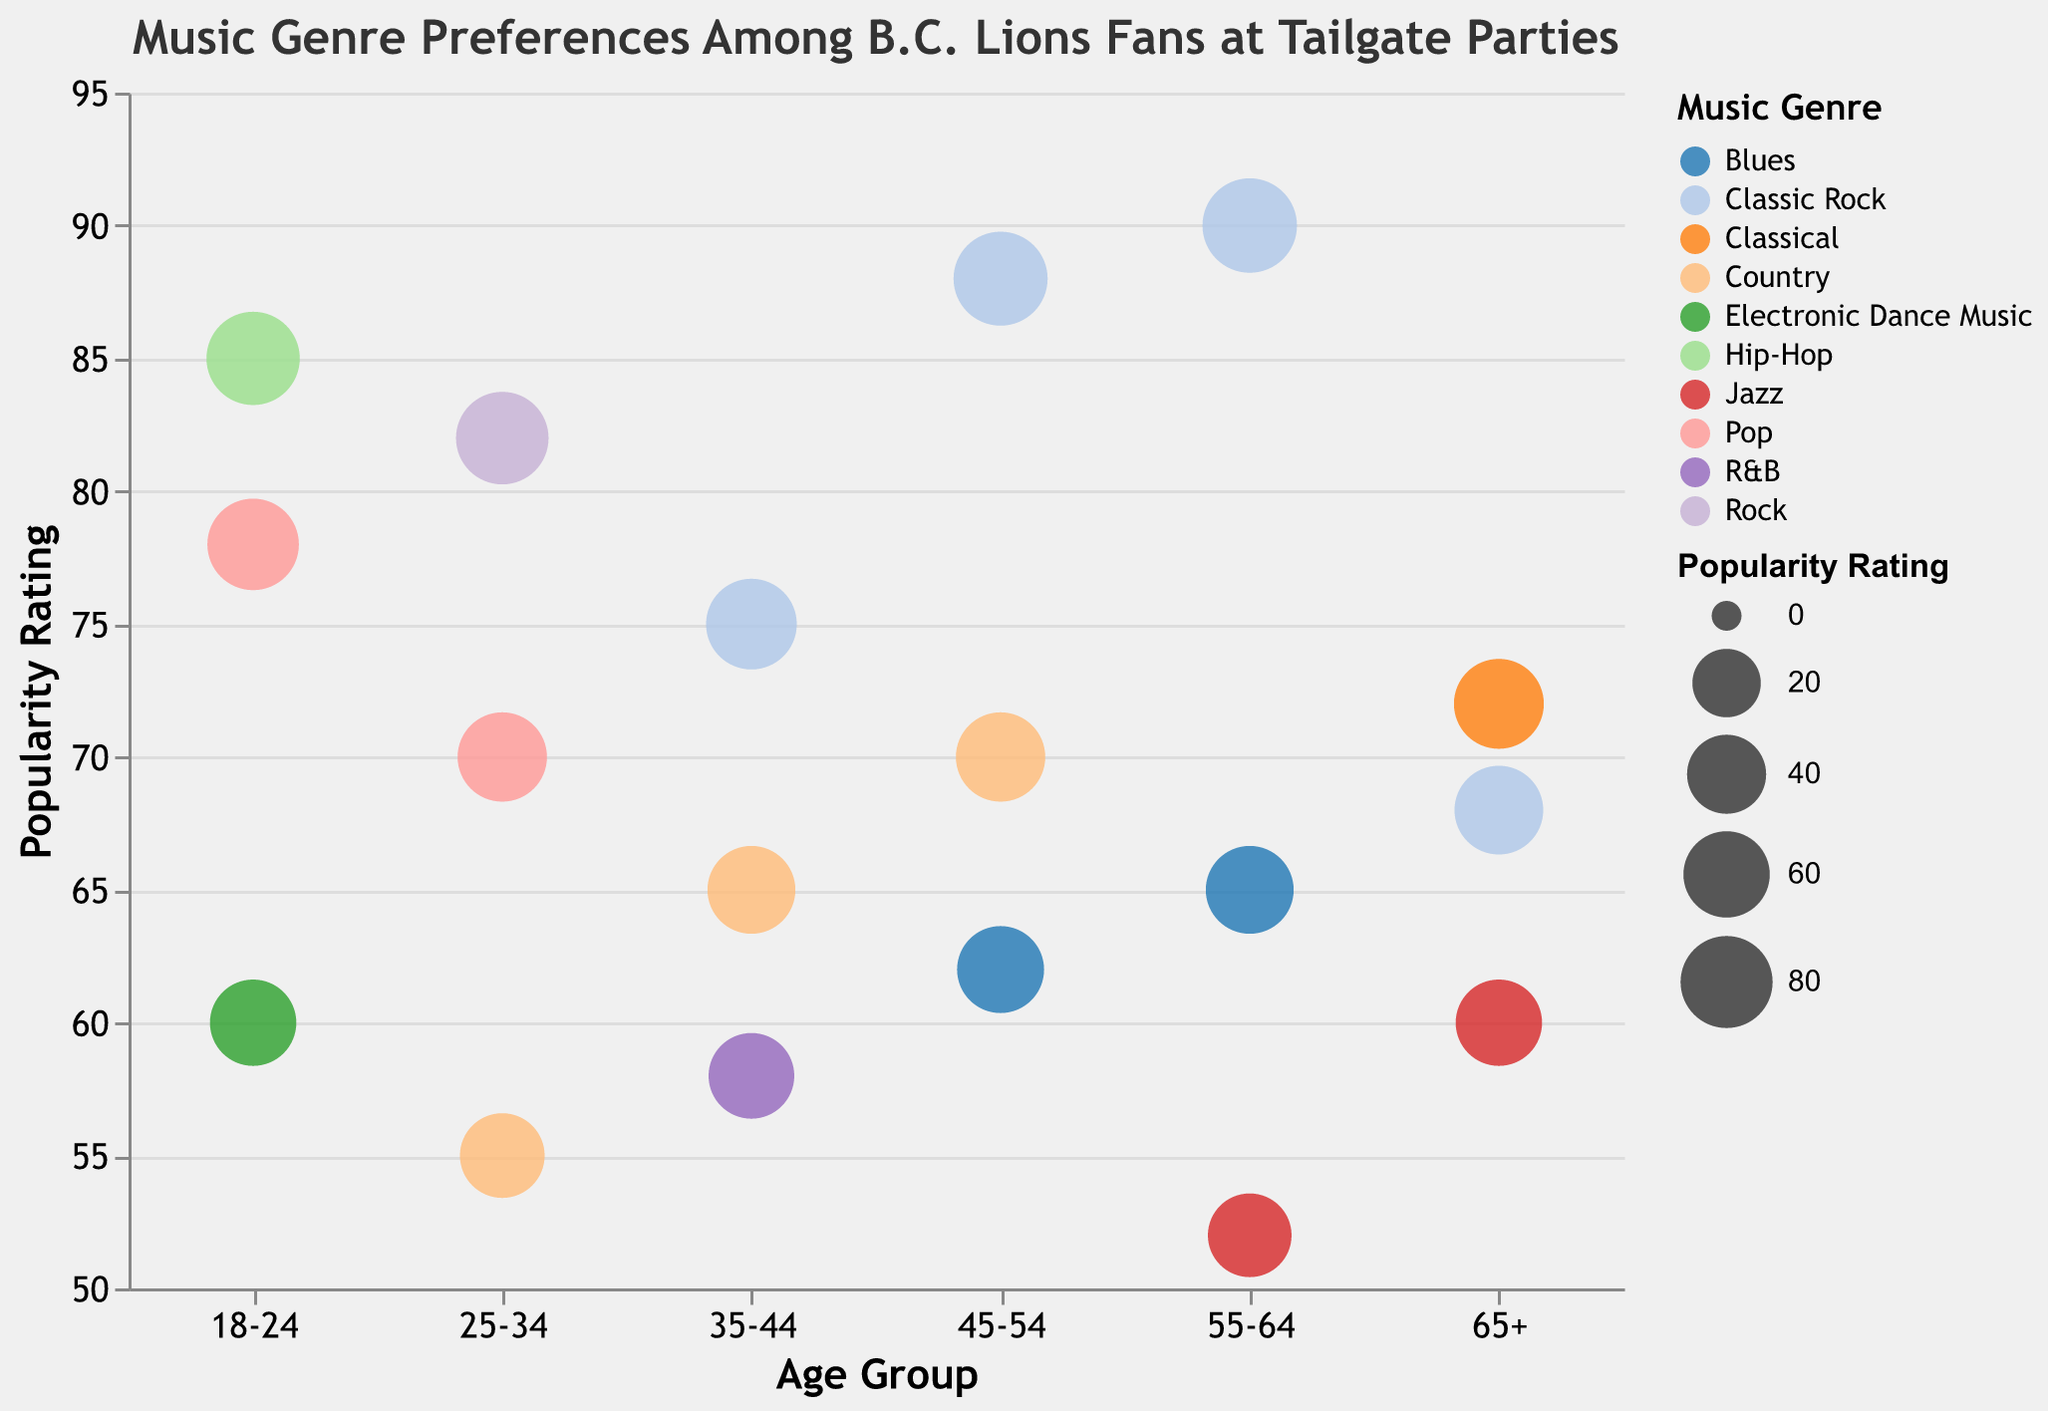What is the most popular music genre for fans aged 18-24? The bubble chart shows a notable concentration of popularity ratings for each music genre. The genre with the highest rating for the age group 18-24 is Hip-Hop with a popularity rating of 85.
Answer: Hip-Hop What is the popularity rating of Classic Rock among fans aged 55-64? Locate the age group 55-64 on the x-axis and find the bubble corresponding to Classic Rock. The popularity rating for Classic Rock in this age group is 90.
Answer: 90 Which age group has the lowest popularity rating for Jazz? To find this, identify the bubbles representing Jazz in each age group and compare their popularity ratings. The age group 55-64 has the lowest popularity rating for Jazz at 52.
Answer: 55-64 How many music genres are shown in the chart for fans aged 65+? Look at the number of distinct bubbles for the age group 65+. Each bubble represents a unique music genre. There are three genres: Jazz, Classical, and Classic Rock.
Answer: 3 Which music genre has a consistent presence across all age groups? By examining the color and label for each bubble across all age groups, Classic Rock is represented in all five age groups: 18-24, 25-34, 35-44, 45-54, and 55-64, and 65+.
Answer: Classic Rock What is the difference in popularity rating between Country music for the age groups 25-34 and 35-44? Country music has a popularity rating of 55 for age group 25-34 and 65 for age group 35-44. The difference is 65 - 55.
Answer: 10 Which age group prefers Blues the most? Identify the popularity rating for Blues across different age groups: 45-54 has a rating of 62, and 55-64 has a rating of 65. The highest rating is 65 for the age group 55-64.
Answer: 55-64 What is the average popularity rating of music genres for fans aged 25-34? Sum the popularity ratings for Pop (70), Rock (82), and Country (55), then divide by the number of genres (3). (70 + 82 + 55) / 3 = 69.
Answer: 69 Which music genre has the highest rating overall in the chart? By comparing the popularity ratings across all bubbles, the highest rating is for Classic Rock in the age group 55-64, which is 90.
Answer: Classic Rock What is the range of popularity ratings for fans aged 45-54? Locate the popularity ratings for the age group 45-54: Classic Rock (88), Blues (62), Country (70). The range is from the highest (88) to the lowest (62), so the range is 88 - 62.
Answer: 26 